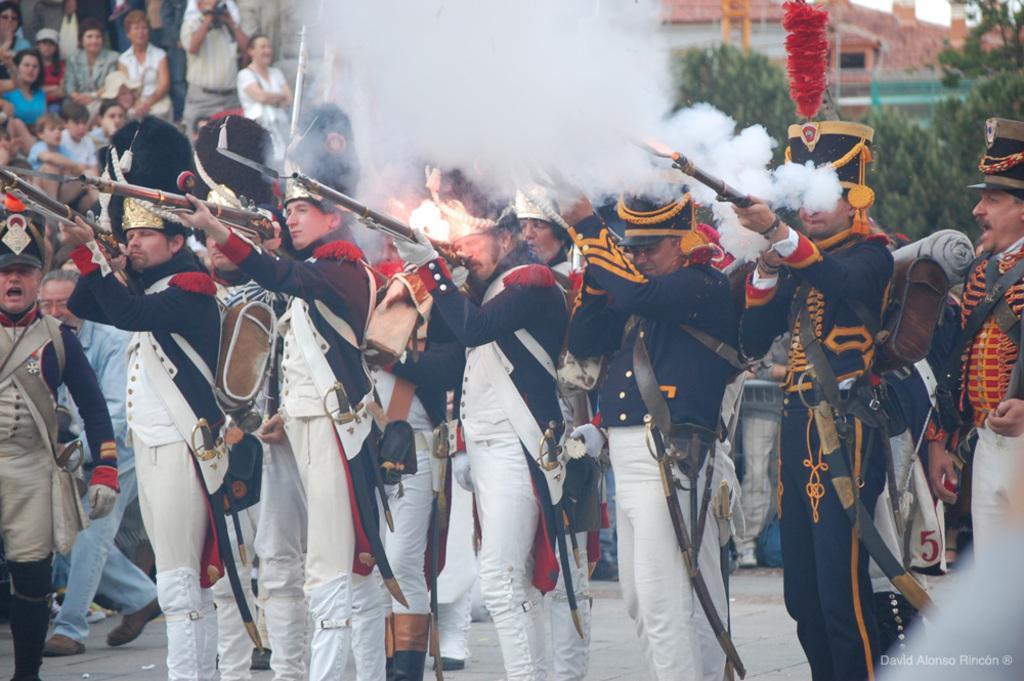In one or two sentences, can you explain what this image depicts? There are many people wearing caps and swords. They are holding guns and shooting. There is smoke. In the background there are many people. Also there are trees. And few are wearing bags. 